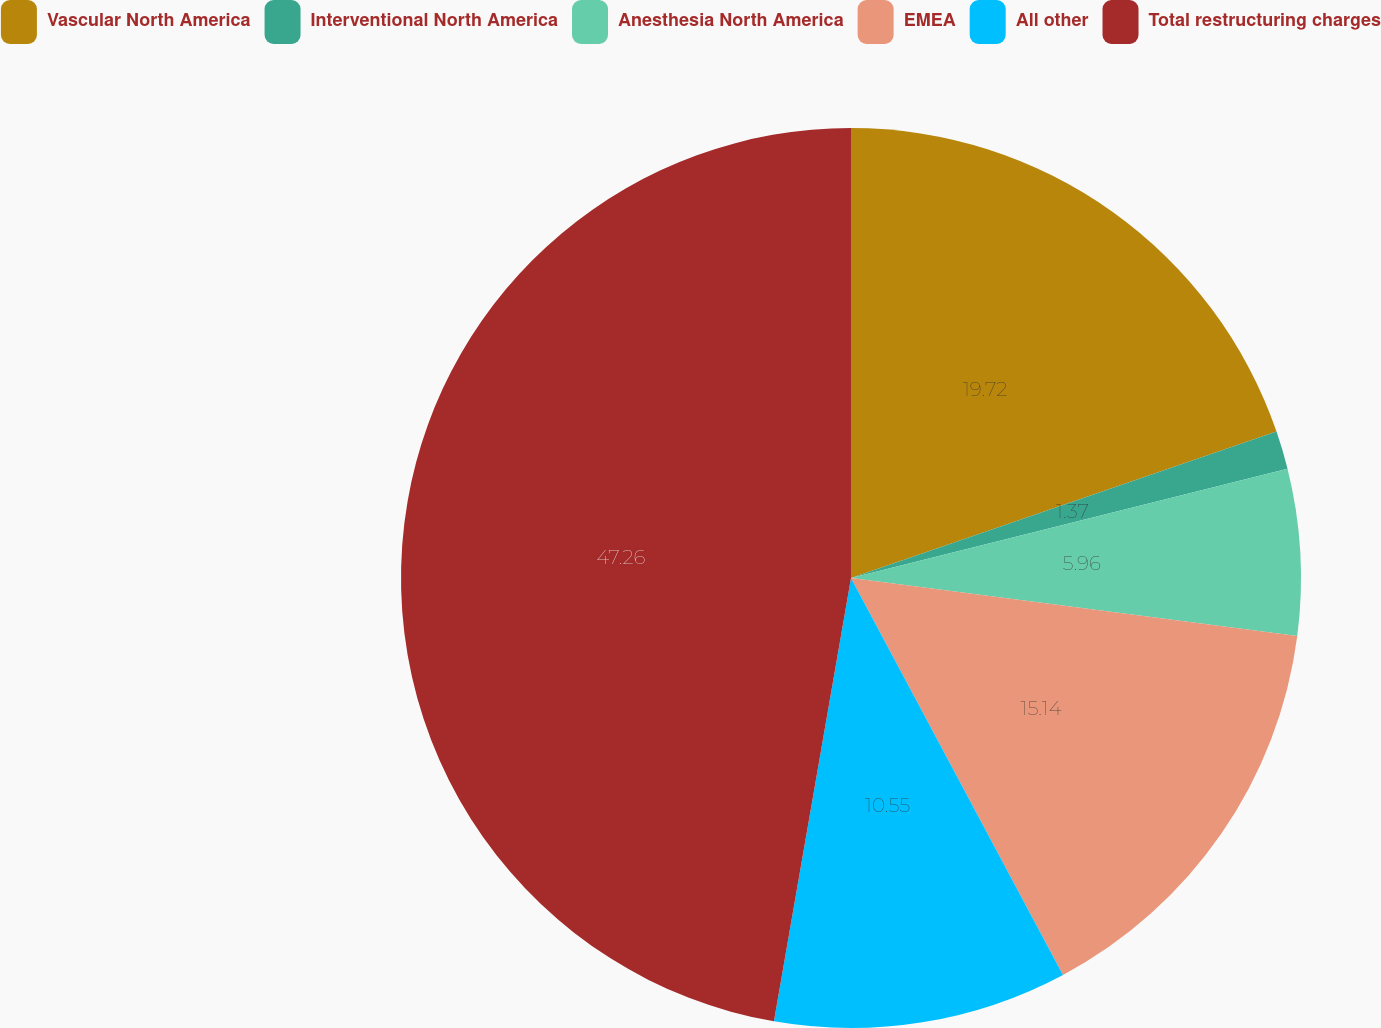Convert chart. <chart><loc_0><loc_0><loc_500><loc_500><pie_chart><fcel>Vascular North America<fcel>Interventional North America<fcel>Anesthesia North America<fcel>EMEA<fcel>All other<fcel>Total restructuring charges<nl><fcel>19.73%<fcel>1.37%<fcel>5.96%<fcel>15.14%<fcel>10.55%<fcel>47.27%<nl></chart> 